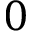<formula> <loc_0><loc_0><loc_500><loc_500>0</formula> 